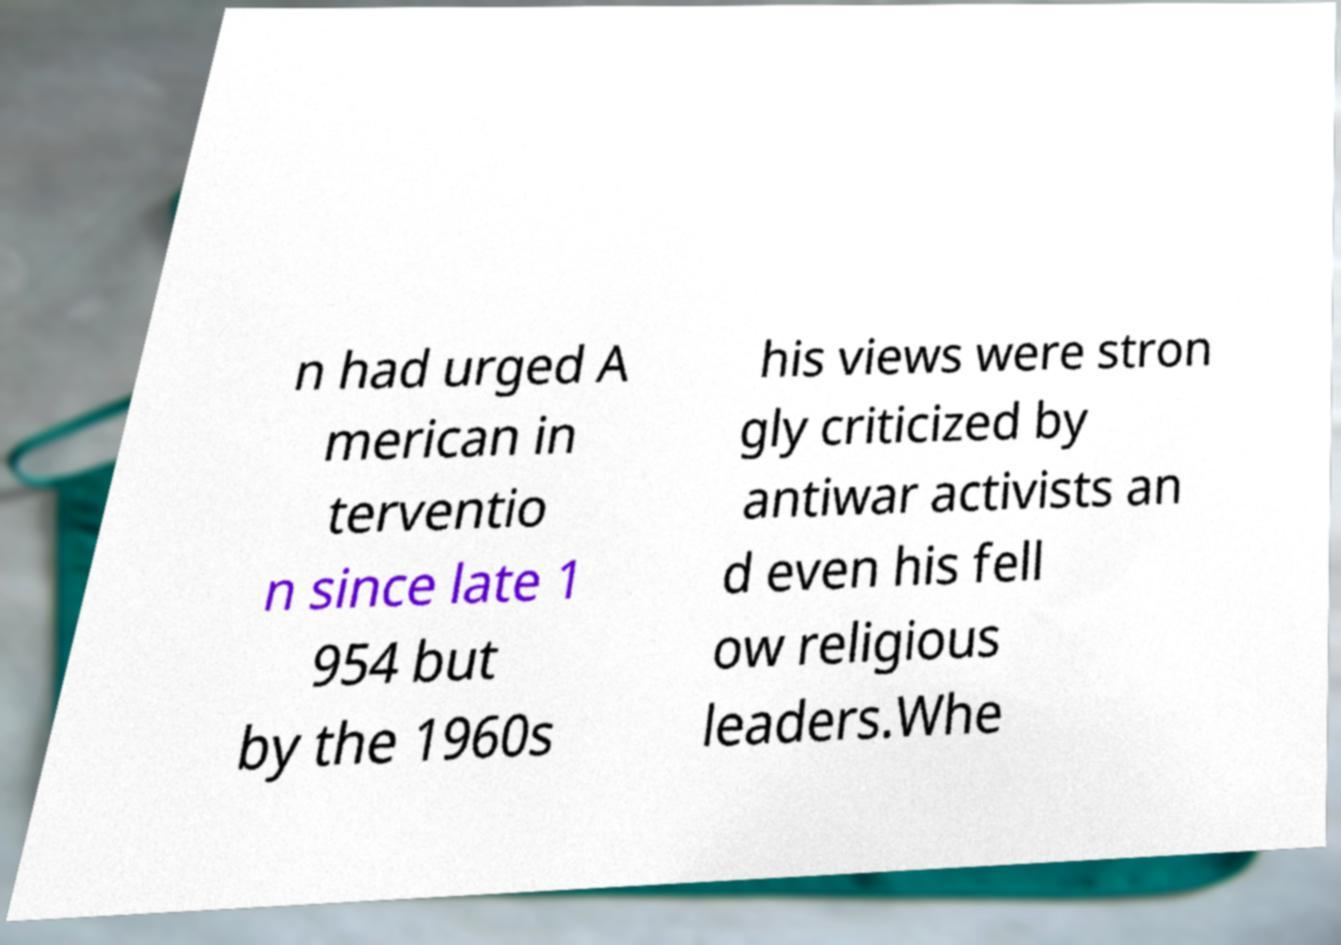Please read and relay the text visible in this image. What does it say? n had urged A merican in terventio n since late 1 954 but by the 1960s his views were stron gly criticized by antiwar activists an d even his fell ow religious leaders.Whe 